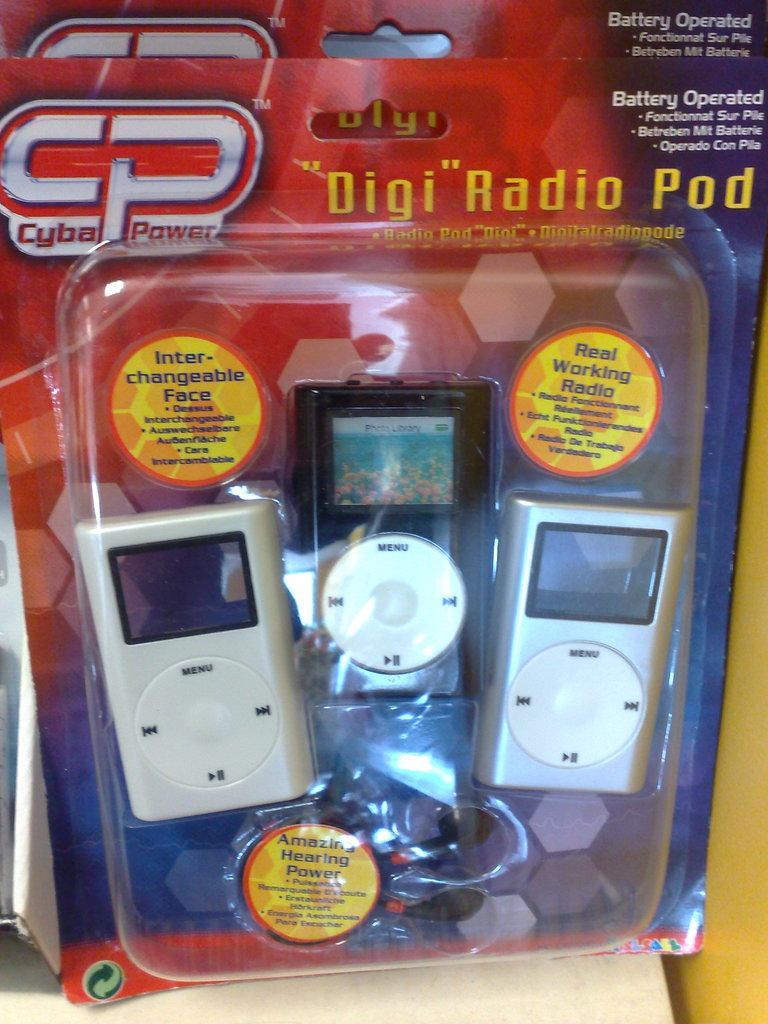In one or two sentences, can you explain what this image depicts? In this image I can see some gadgets. 